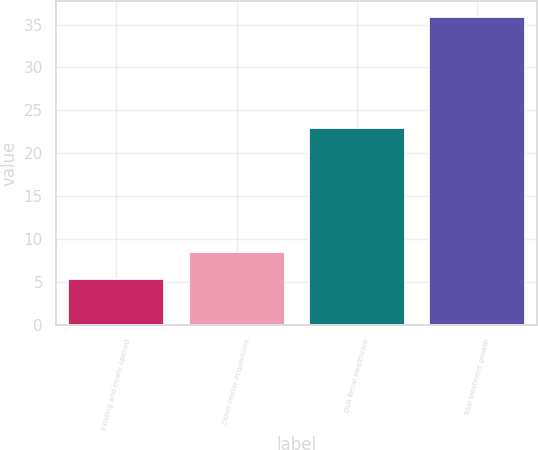<chart> <loc_0><loc_0><loc_500><loc_500><bar_chart><fcel>Existing and newly opened<fcel>Other center acquisitions<fcel>DVA Renal Healthcare<fcel>Total treatment growth<nl><fcel>5.4<fcel>8.45<fcel>23<fcel>35.9<nl></chart> 